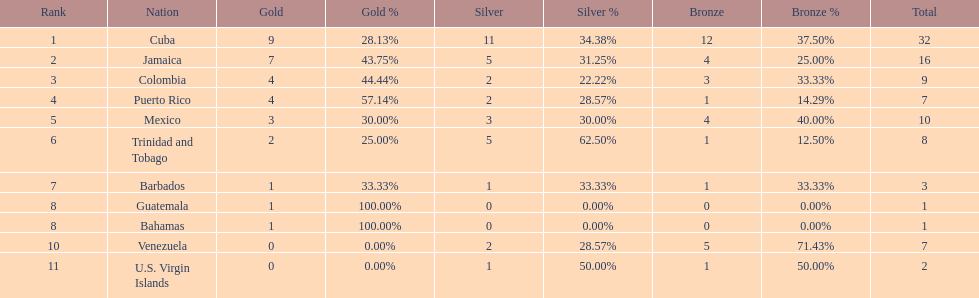Which country was awarded more than 5 silver medals? Cuba. 